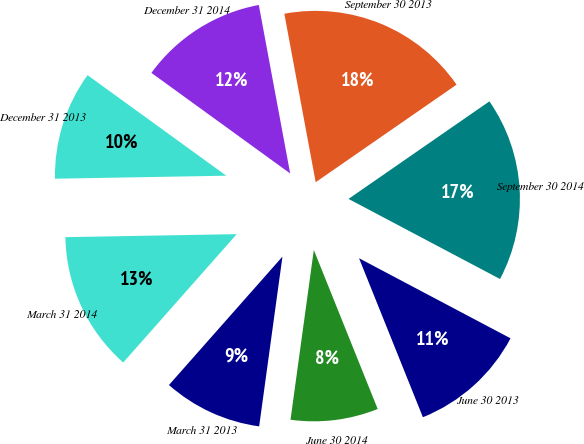Convert chart to OTSL. <chart><loc_0><loc_0><loc_500><loc_500><pie_chart><fcel>March 31 2014<fcel>March 31 2013<fcel>June 30 2014<fcel>June 30 2013<fcel>September 30 2014<fcel>September 30 2013<fcel>December 31 2014<fcel>December 31 2013<nl><fcel>13.2%<fcel>9.35%<fcel>8.25%<fcel>11.18%<fcel>17.38%<fcel>18.29%<fcel>12.09%<fcel>10.26%<nl></chart> 